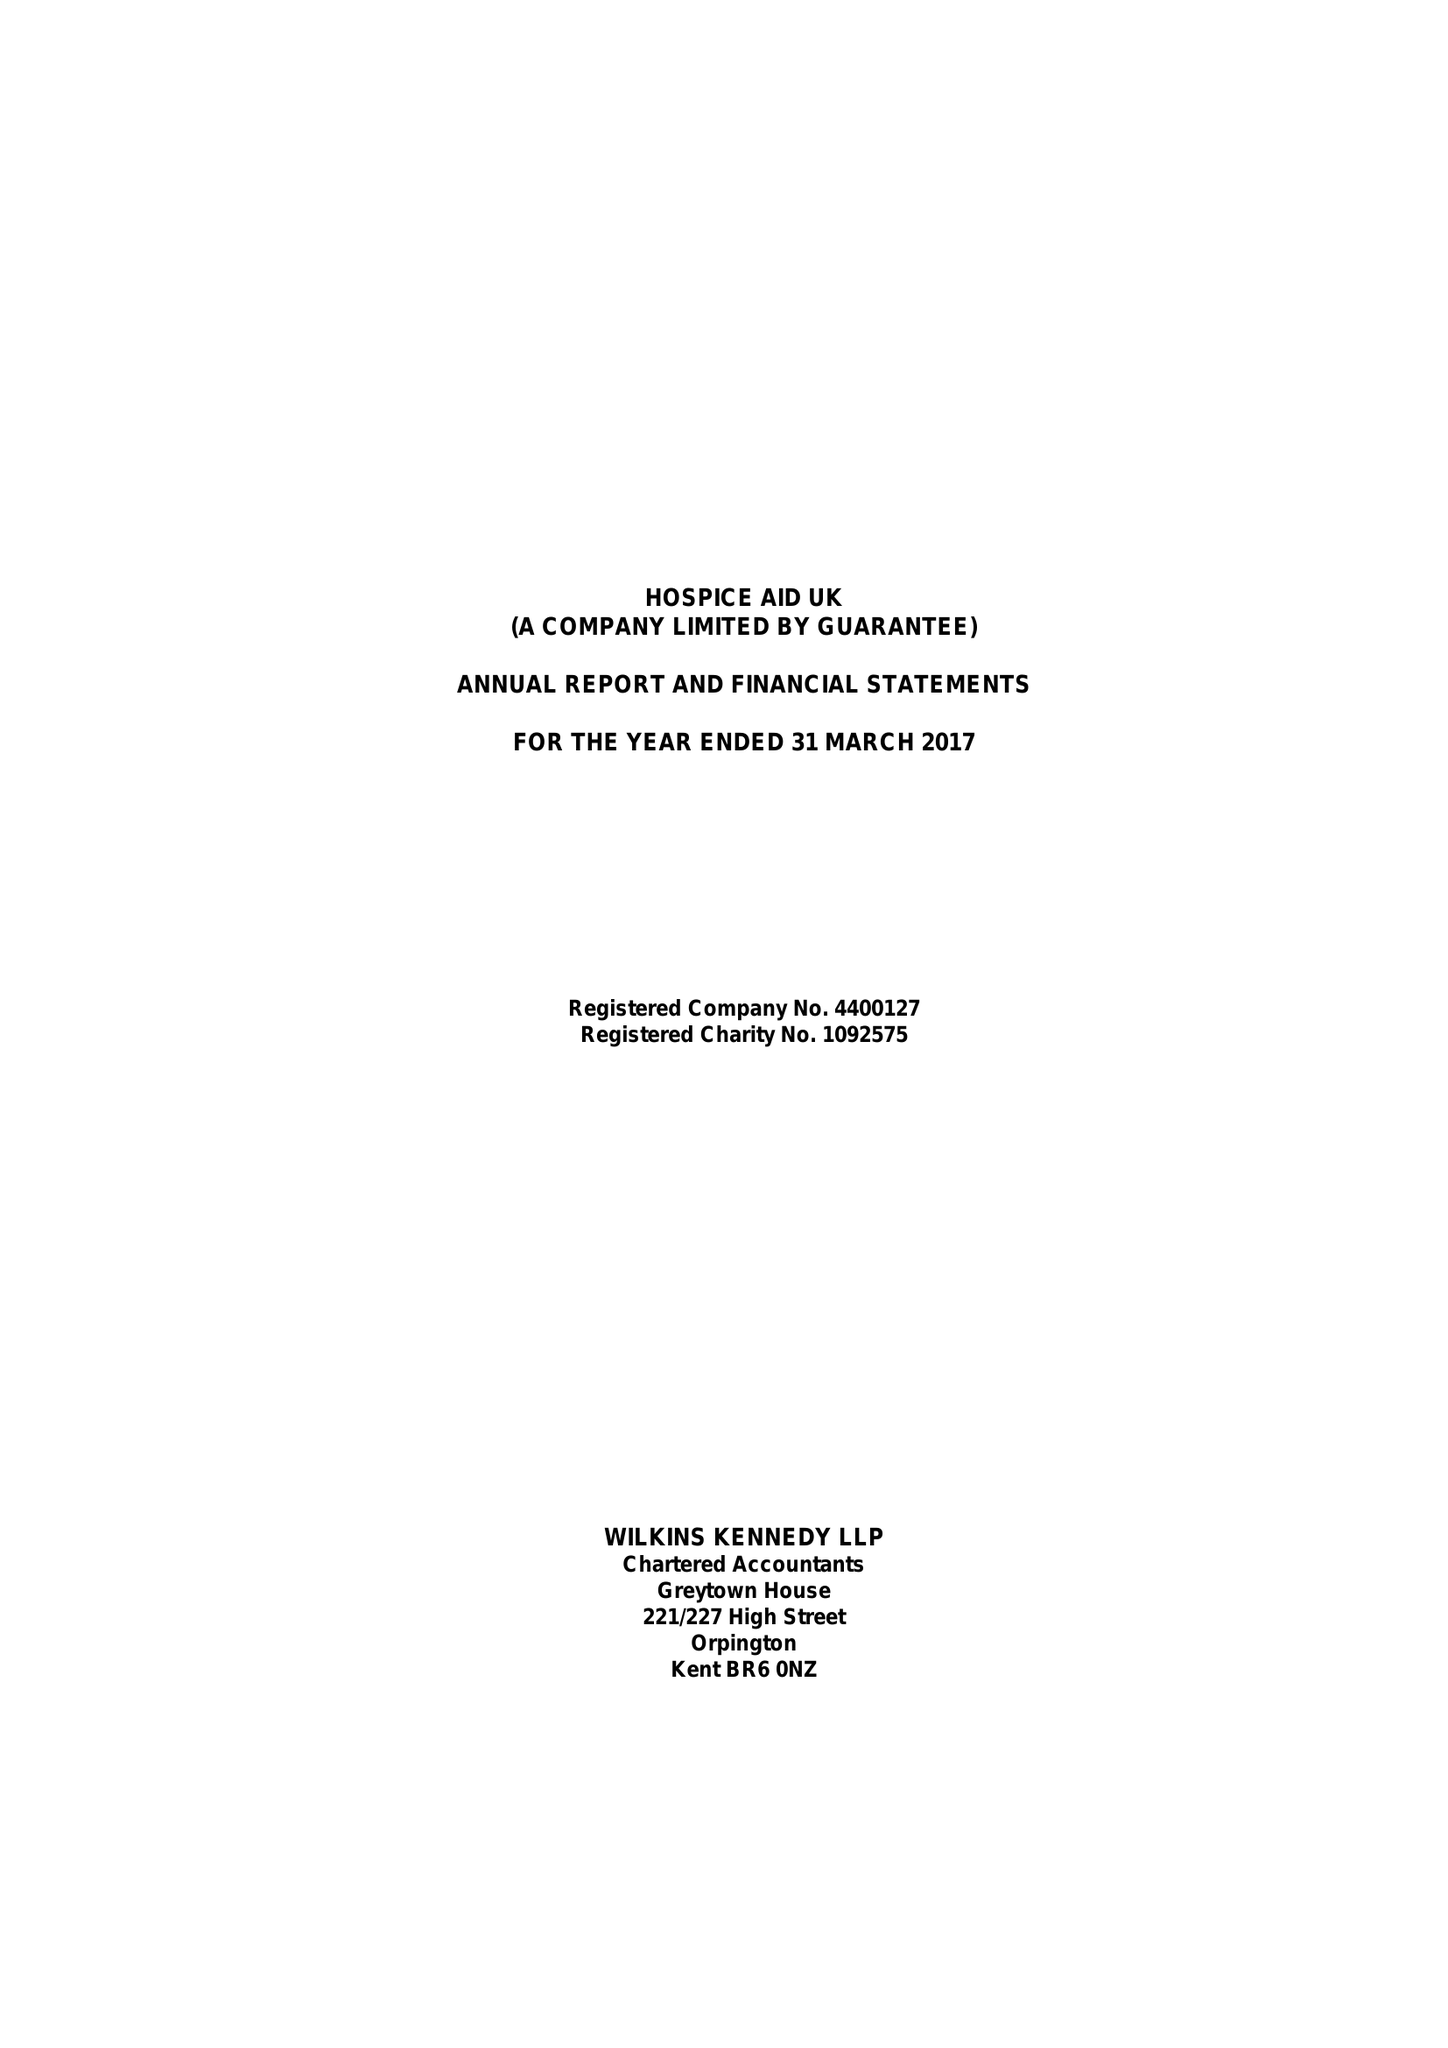What is the value for the spending_annually_in_british_pounds?
Answer the question using a single word or phrase. 527480.00 